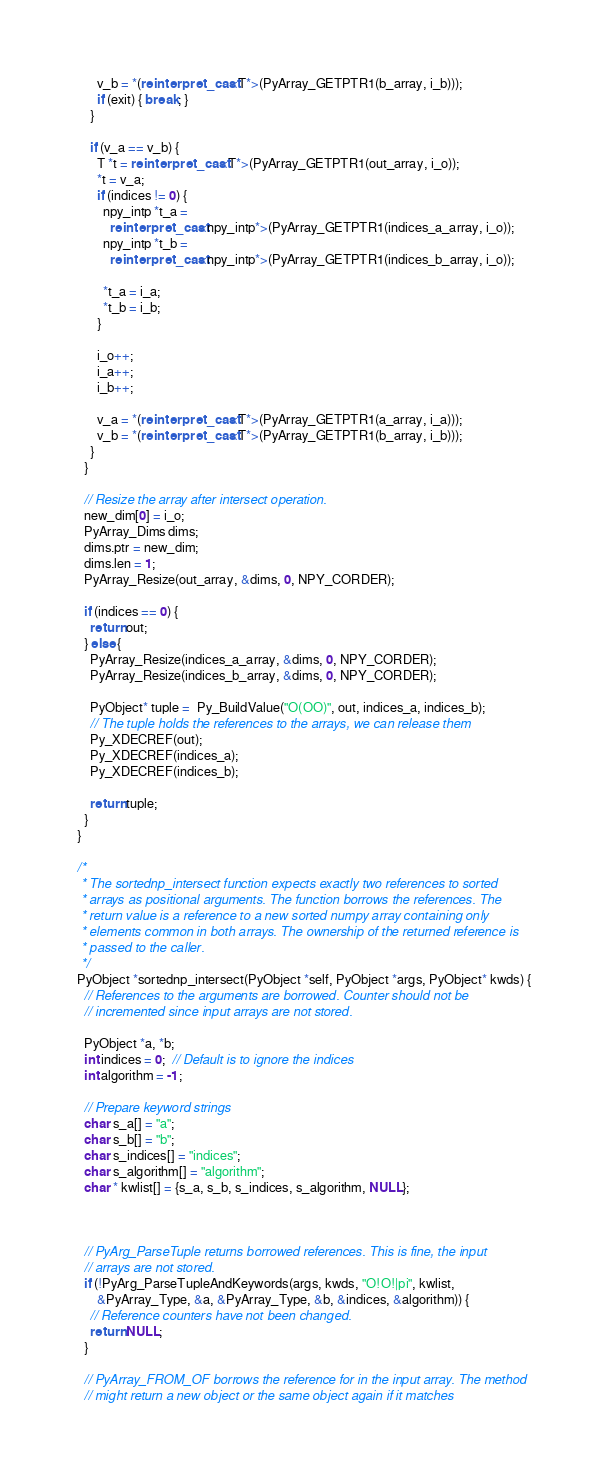<code> <loc_0><loc_0><loc_500><loc_500><_C++_>      v_b = *(reinterpret_cast<T*>(PyArray_GETPTR1(b_array, i_b)));
      if (exit) { break; }
    }

    if (v_a == v_b) {
      T *t = reinterpret_cast<T*>(PyArray_GETPTR1(out_array, i_o));
      *t = v_a;
      if (indices != 0) {
        npy_intp *t_a =
          reinterpret_cast<npy_intp*>(PyArray_GETPTR1(indices_a_array, i_o));
        npy_intp *t_b =
          reinterpret_cast<npy_intp*>(PyArray_GETPTR1(indices_b_array, i_o));

        *t_a = i_a;
        *t_b = i_b;
      }

      i_o++;
      i_a++;
      i_b++;

      v_a = *(reinterpret_cast<T*>(PyArray_GETPTR1(a_array, i_a)));
      v_b = *(reinterpret_cast<T*>(PyArray_GETPTR1(b_array, i_b)));
    }
  }

  // Resize the array after intersect operation.
  new_dim[0] = i_o;
  PyArray_Dims dims;
  dims.ptr = new_dim;
  dims.len = 1;
  PyArray_Resize(out_array, &dims, 0, NPY_CORDER);

  if (indices == 0) {
    return out;
  } else {
    PyArray_Resize(indices_a_array, &dims, 0, NPY_CORDER);
    PyArray_Resize(indices_b_array, &dims, 0, NPY_CORDER);

    PyObject* tuple =  Py_BuildValue("O(OO)", out, indices_a, indices_b);
    // The tuple holds the references to the arrays, we can release them
    Py_XDECREF(out);
    Py_XDECREF(indices_a);
    Py_XDECREF(indices_b);

    return tuple;
  }
}

/*
 * The sortednp_intersect function expects exactly two references to sorted
 * arrays as positional arguments. The function borrows the references. The
 * return value is a reference to a new sorted numpy array containing only
 * elements common in both arrays. The ownership of the returned reference is
 * passed to the caller.
 */
PyObject *sortednp_intersect(PyObject *self, PyObject *args, PyObject* kwds) {
  // References to the arguments are borrowed. Counter should not be
  // incremented since input arrays are not stored.

  PyObject *a, *b;
  int indices = 0;  // Default is to ignore the indices
  int algorithm = -1;

  // Prepare keyword strings
  char s_a[] = "a";
  char s_b[] = "b";
  char s_indices[] = "indices";
  char s_algorithm[] = "algorithm";
  char * kwlist[] = {s_a, s_b, s_indices, s_algorithm, NULL};



  // PyArg_ParseTuple returns borrowed references. This is fine, the input
  // arrays are not stored.
  if (!PyArg_ParseTupleAndKeywords(args, kwds, "O!O!|pi", kwlist,
      &PyArray_Type, &a, &PyArray_Type, &b, &indices, &algorithm)) {
    // Reference counters have not been changed.
    return NULL;
  }

  // PyArray_FROM_OF borrows the reference for in the input array. The method
  // might return a new object or the same object again if it matches</code> 